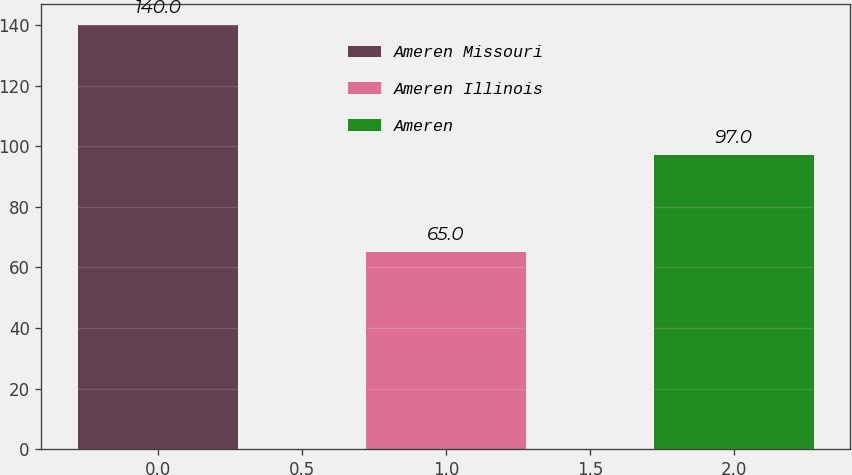<chart> <loc_0><loc_0><loc_500><loc_500><bar_chart><fcel>Ameren Missouri<fcel>Ameren Illinois<fcel>Ameren<nl><fcel>140<fcel>65<fcel>97<nl></chart> 